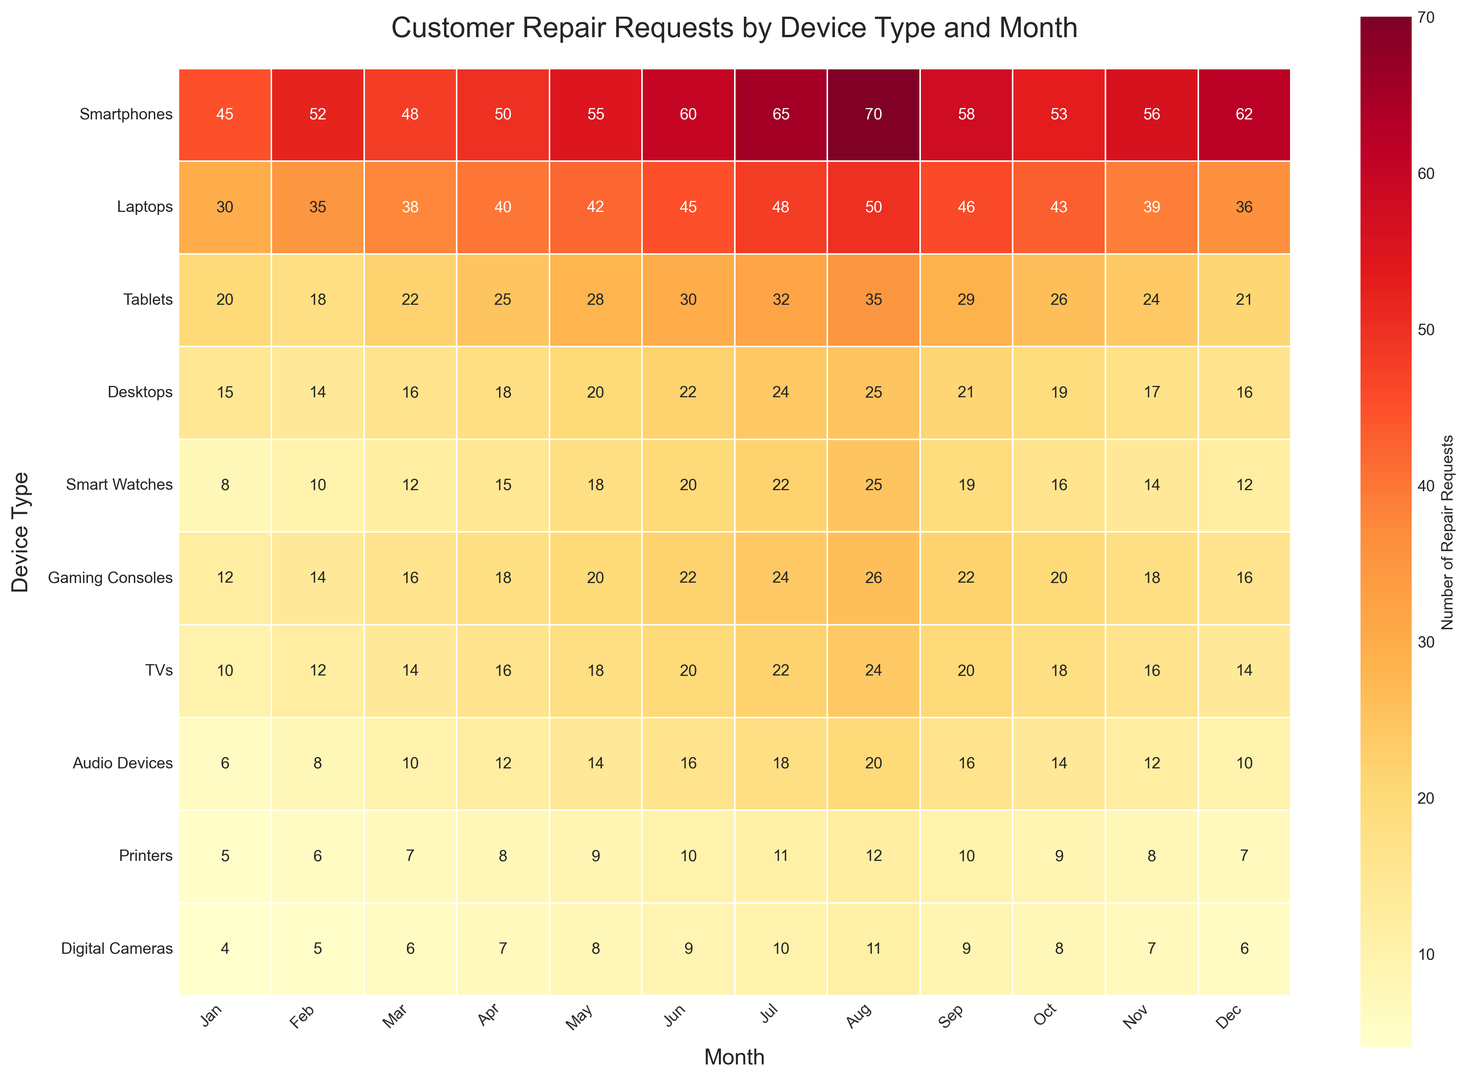Which device type had the highest number of repair requests overall for the year? Looking at the heatmap, the device type with the darkest red cells for most of the months indicates the highest number of repair requests. Smartphones consistently have the highest values across the months.
Answer: Smartphones What's the average number of repair requests for Laptops in the first quarter (Jan-Mar)? Sum the number of repair requests for Laptops in January, February, and March (30 + 35 + 38), then divide by 3.
Answer: Average = (30 + 35 + 38) / 3 = 34.33 Which month had the highest number of repair requests for Smart Watches? Refer to the heatmap and find the month with the darkest red cell in the row for Smart Watches. August has the highest number with 25 requests.
Answer: August How does the number of repair requests for Gaming Consoles in May compare to the number in November? Locate May and November in the row for Gaming Consoles. May has 20 requests, and November has 18 requests. Therefore, May had slightly more repair requests than November.
Answer: May > November Which device type had the lowest number of repair requests in December? Check the cells in the December column and find the lightest (least red) cell. Digital Cameras had the fewest repair requests in December with 6.
Answer: Digital Cameras What is the total number of repair requests for all devices in July? Sum the numbers in the July column: 65 + 48 + 32 + 24 + 22 + 24 + 22 + 18 + 11 + 10 = 276.
Answer: 276 In which month(s) did Desktops see the highest increase in repair requests compared to the previous month? Compare the number of repair requests from one month to the next for Desktops. April to May shows the highest increase from 18 to 20.
Answer: May What is the color representation for the number of repair requests for TVs in October? Look at the color of the cell representing TVs in October. The cell is a medium red shade, associated with 18 repair requests.
Answer: Red Compare the number of repair requests for Audio Devices in the second quarter (Apr-Jun) versus the fourth quarter (Oct-Dec). Which quarter had more requests? Sum the requests for April, May, and June (12 + 14 + 16 = 42) and for October, November, and December (14 + 12 + 10 = 36). The second quarter had more requests.
Answer: Q2 > Q4 